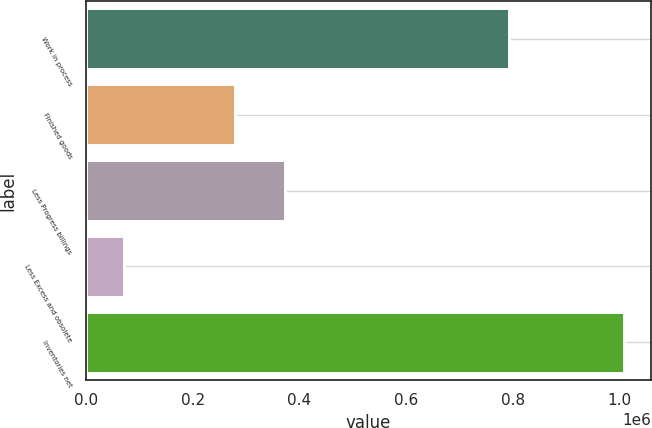Convert chart to OTSL. <chart><loc_0><loc_0><loc_500><loc_500><bar_chart><fcel>Work in process<fcel>Finished goods<fcel>Less Progress billings<fcel>Less Excess and obsolete<fcel>Inventories net<nl><fcel>793053<fcel>279267<fcel>372892<fcel>72127<fcel>1.00838e+06<nl></chart> 